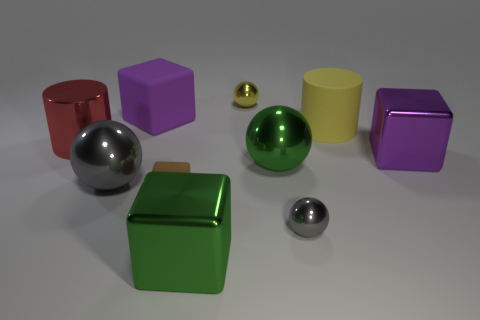How big is the brown matte block?
Your answer should be very brief. Small. What is the color of the other sphere that is the same size as the green sphere?
Make the answer very short. Gray. Is there a big thing of the same color as the tiny rubber block?
Your response must be concise. No. What material is the small gray sphere?
Ensure brevity in your answer.  Metal. What number of large red things are there?
Make the answer very short. 1. Does the large metallic sphere that is to the right of the large purple rubber thing have the same color as the metal cube to the left of the yellow sphere?
Ensure brevity in your answer.  Yes. The metallic object that is the same color as the matte cylinder is what size?
Keep it short and to the point. Small. How many other objects are there of the same size as the green sphere?
Keep it short and to the point. 6. There is a small metallic thing that is behind the large yellow matte cylinder; what is its color?
Provide a succinct answer. Yellow. Are the purple thing to the left of the tiny rubber cube and the small brown thing made of the same material?
Your response must be concise. Yes. 